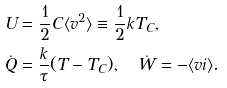Convert formula to latex. <formula><loc_0><loc_0><loc_500><loc_500>U & = \frac { 1 } { 2 } C \langle v ^ { 2 } \rangle \equiv \frac { 1 } { 2 } k T _ { C } , \\ \dot { Q } & = \frac { k } { \tau } ( T - T _ { C } ) , \quad \dot { W } = - \langle v i \rangle .</formula> 